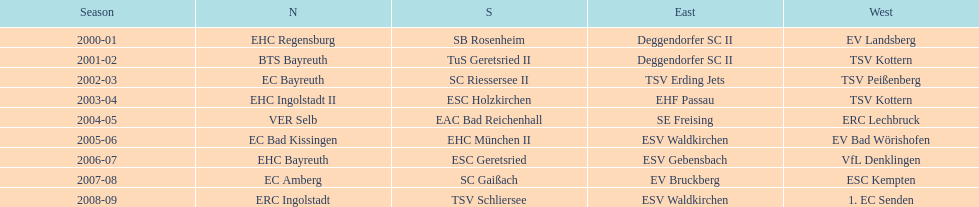Who won the season in the north before ec bayreuth did in 2002-03? BTS Bayreuth. 